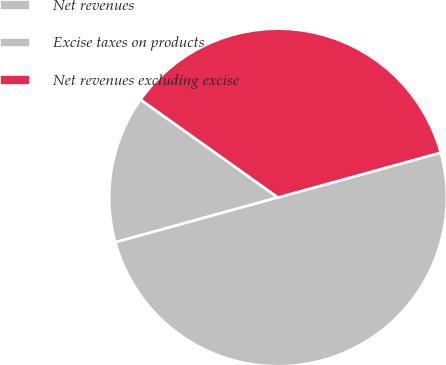Convert chart to OTSL. <chart><loc_0><loc_0><loc_500><loc_500><pie_chart><fcel>Net revenues<fcel>Excise taxes on products<fcel>Net revenues excluding excise<nl><fcel>14.13%<fcel>50.0%<fcel>35.87%<nl></chart> 